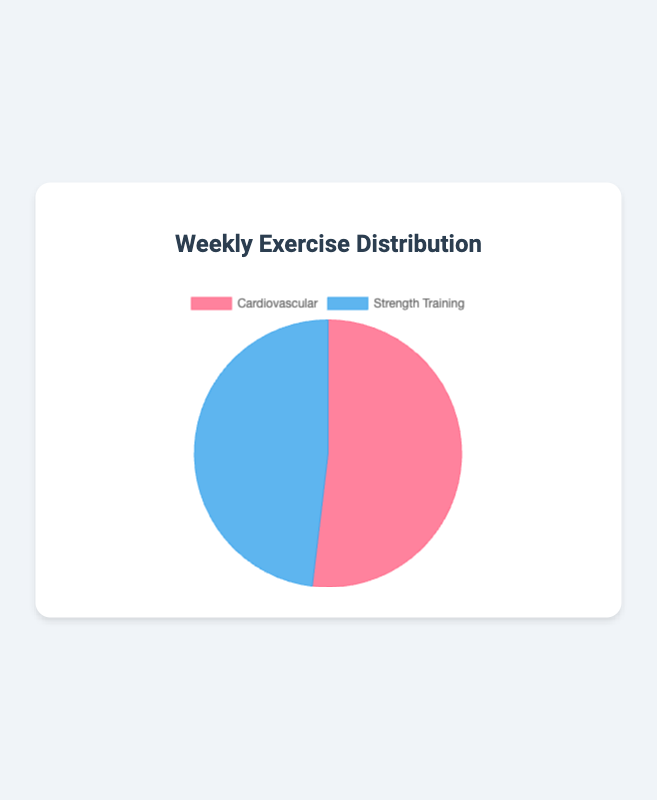How much time is spent on Cardiovascular exercise for the entire week? Sum the time spent on cardiovascular exercise each day: 45 (Mon) + 60 (Tue) + 30 (Wed) + 50 (Thu) + 40 (Fri) + 30 (Sat) + 20 (Sun) = 275 minutes
Answer: 275 minutes Which type of exercise has a higher total duration for the week? Compare the total time: Cardiovascular (275 minutes) vs. Strength Training (255 minutes). Cardiovascular has a higher total duration.
Answer: Cardiovascular What's the percentage of time spent on Strength Training compared to the total exercise time? Calculate the total exercise time: 275 (Cardio) + 255 (Strength) = 530 minutes. Then calculate the percentage: (255 / 530) * 100 ≈ 48.11%
Answer: ~48.11% Is the time spent on Strength Training more than Cardiovascular exercise on weekends? Compare the minutes spent on Saturday and Sunday: Cardio (30 + 20 = 50 minutes) vs. Strength (60 + 30 = 90 minutes). Strength Training is more.
Answer: Yes What's the difference in time spent on Cardiovascular between Tuesday and Sunday? Subtract the time: 60 (Tuesday) - 20 (Sunday) = 40 minutes.
Answer: 40 minutes What is the average time spent on Strength Training across the week? Sum the strength training times [30 + 20 + 40 + 30 + 45 + 60 + 30] = 255. Divide by 7: 255/7 ≈ 36.43 minutes
Answer: ~36.43 minutes Which day has the highest total exercise time? Calculate the total exercise time per day: 
- Monday (45 + 30 = 75 minutes), 
- Tuesday (60 + 20 = 80 minutes), 
- Wednesday (30 + 40 = 70 minutes), 
- Thursday (50 + 30 = 80 minutes), 
- Friday (40 + 45 = 85 minutes), 
- Saturday (30 + 60 = 90 minutes), 
- Sunday (20 + 30 = 50 minutes). 
Saturday has the highest total exercise time: 90 minutes.
Answer: Saturday How many days have more than 60 minutes of Cardiovascular exercise? Find days with cardio minutes > 60: Only Tuesday (60 minutes) doesn't exceed. 0 days exceed 60 minutes.
Answer: 0 What proportion of total exercise time was spent on each type of exercise? Calculate the proportions: For Cardiovascular, 275 / 530 = 0.5189 ≈ 51.89%; For Strength, 255 / 530 = 0.4811 ≈ 48.11%
Answer: Cardio ~51.89%, Strength ~48.11% 